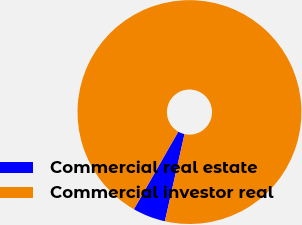<chart> <loc_0><loc_0><loc_500><loc_500><pie_chart><fcel>Commercial real estate<fcel>Commercial investor real<nl><fcel>4.74%<fcel>95.26%<nl></chart> 